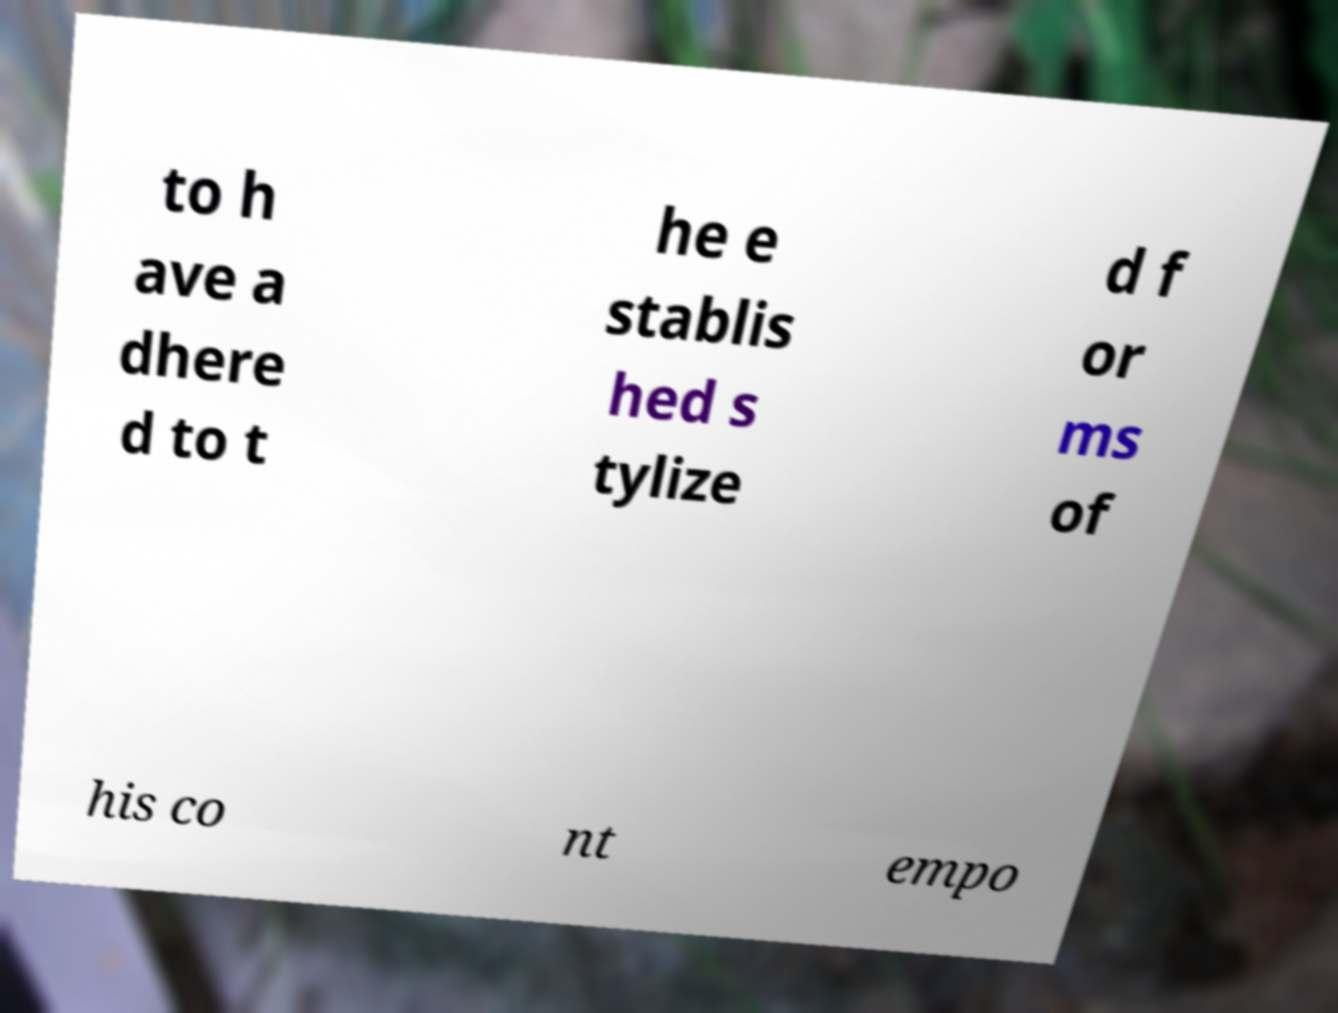Can you accurately transcribe the text from the provided image for me? to h ave a dhere d to t he e stablis hed s tylize d f or ms of his co nt empo 